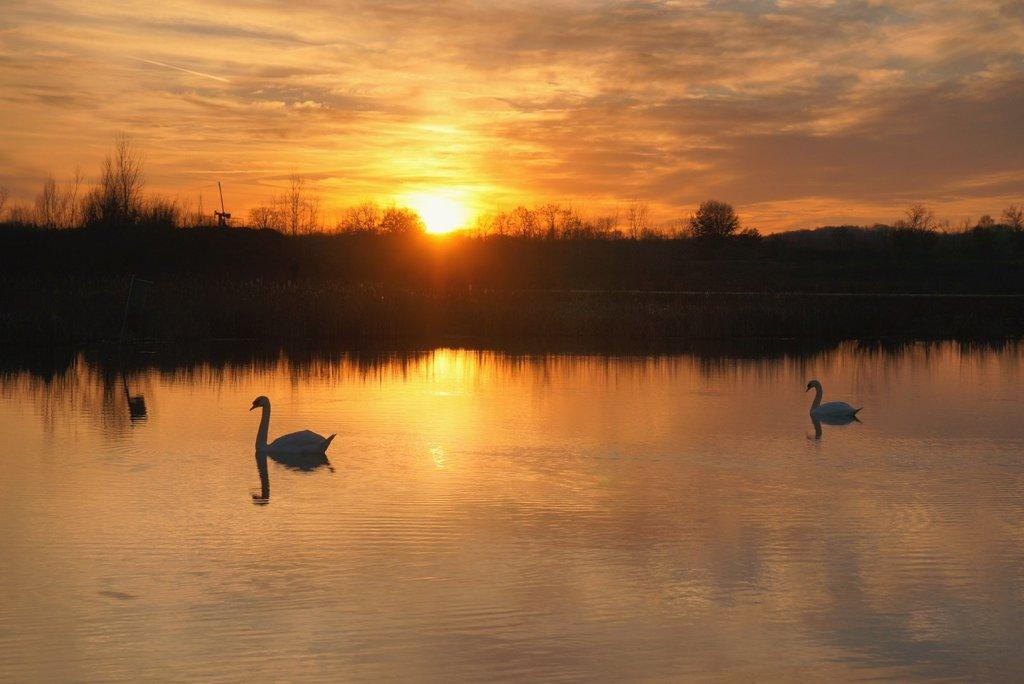What is in the foreground of the picture? There is a water body in the foreground of the picture. What animals can be seen in the water? There are swans in the water. What is located in the center of the picture? There are trees in the center of the picture. What can be seen in the background of the picture? The sky is visible in the background of the picture. What celestial body is present in the sky? The sun is present in the sky. What grade is the cactus in the image? There is no cactus present in the image. Who is the authority figure in the image? There is no authority figure present in the image. 